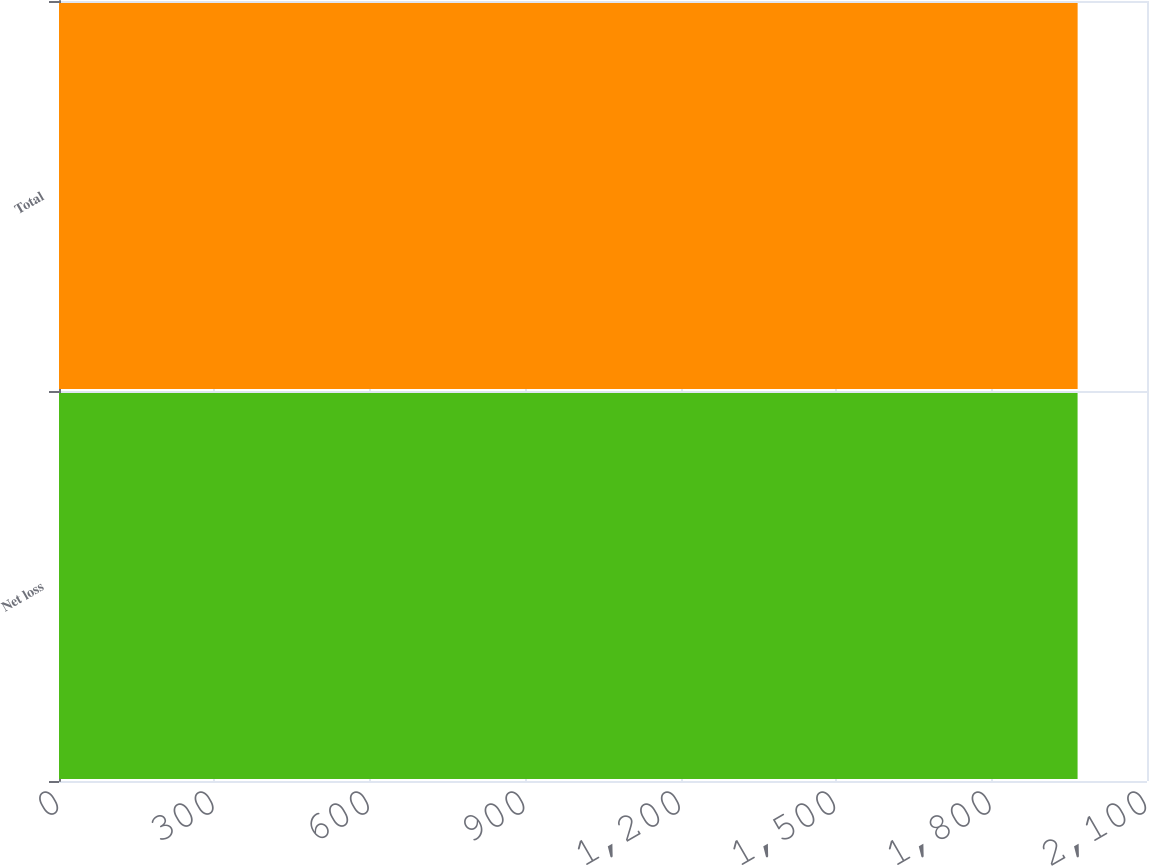<chart> <loc_0><loc_0><loc_500><loc_500><bar_chart><fcel>Net loss<fcel>Total<nl><fcel>1966<fcel>1966.1<nl></chart> 